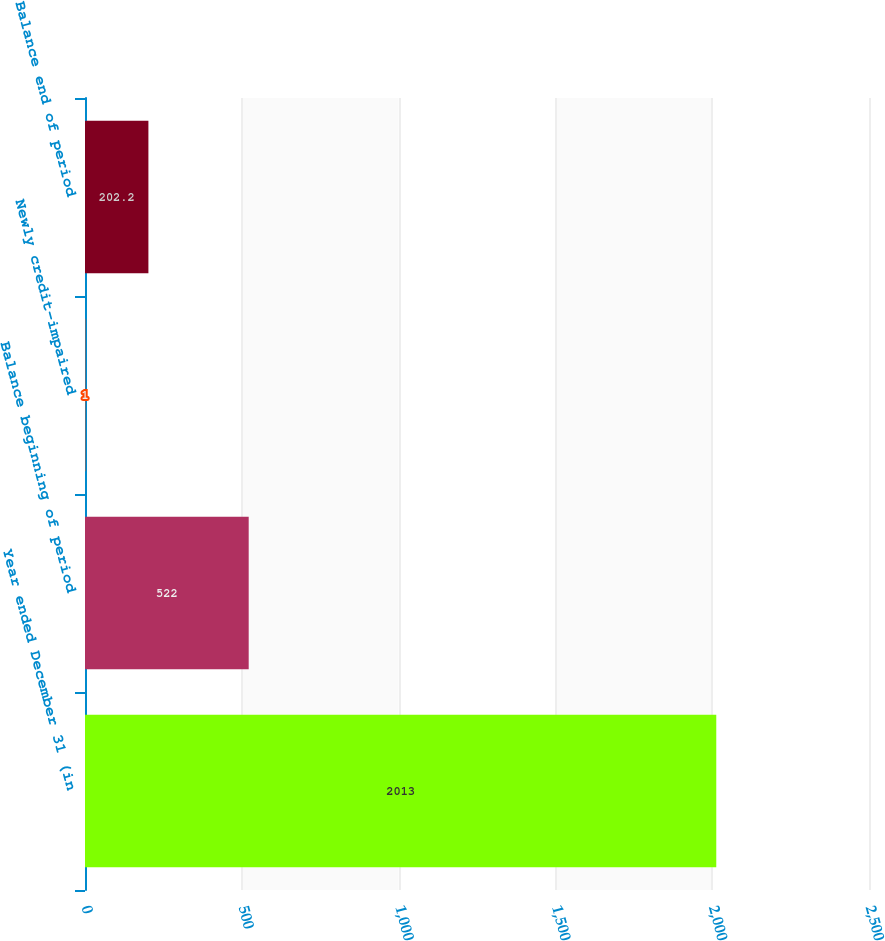Convert chart. <chart><loc_0><loc_0><loc_500><loc_500><bar_chart><fcel>Year ended December 31 (in<fcel>Balance beginning of period<fcel>Newly credit-impaired<fcel>Balance end of period<nl><fcel>2013<fcel>522<fcel>1<fcel>202.2<nl></chart> 